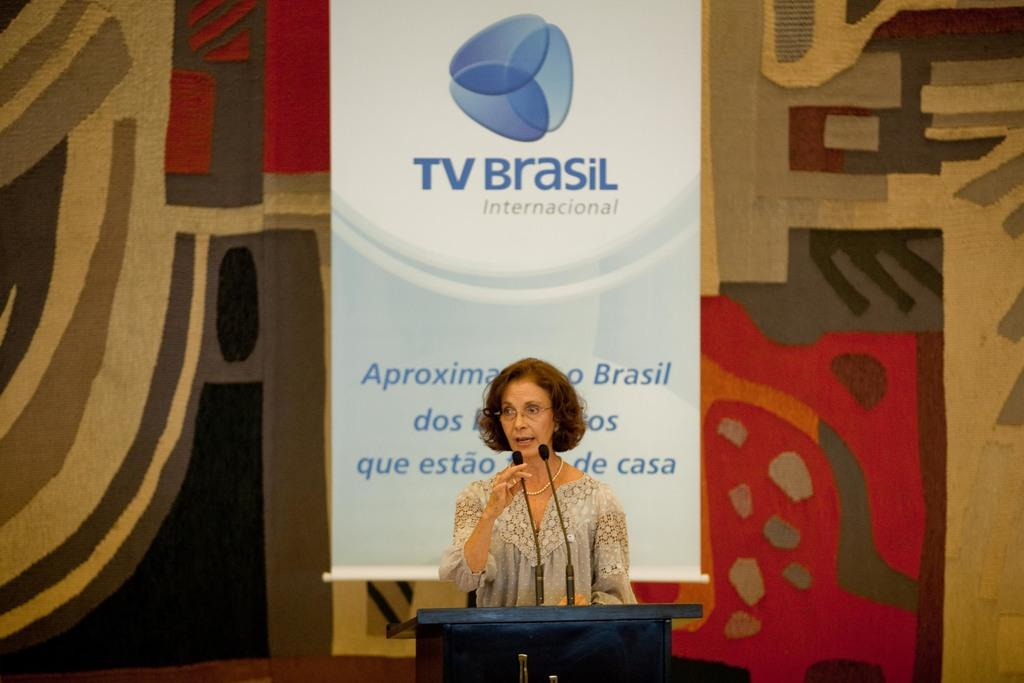<image>
Provide a brief description of the given image. a lady in front of a tv brasil sign 